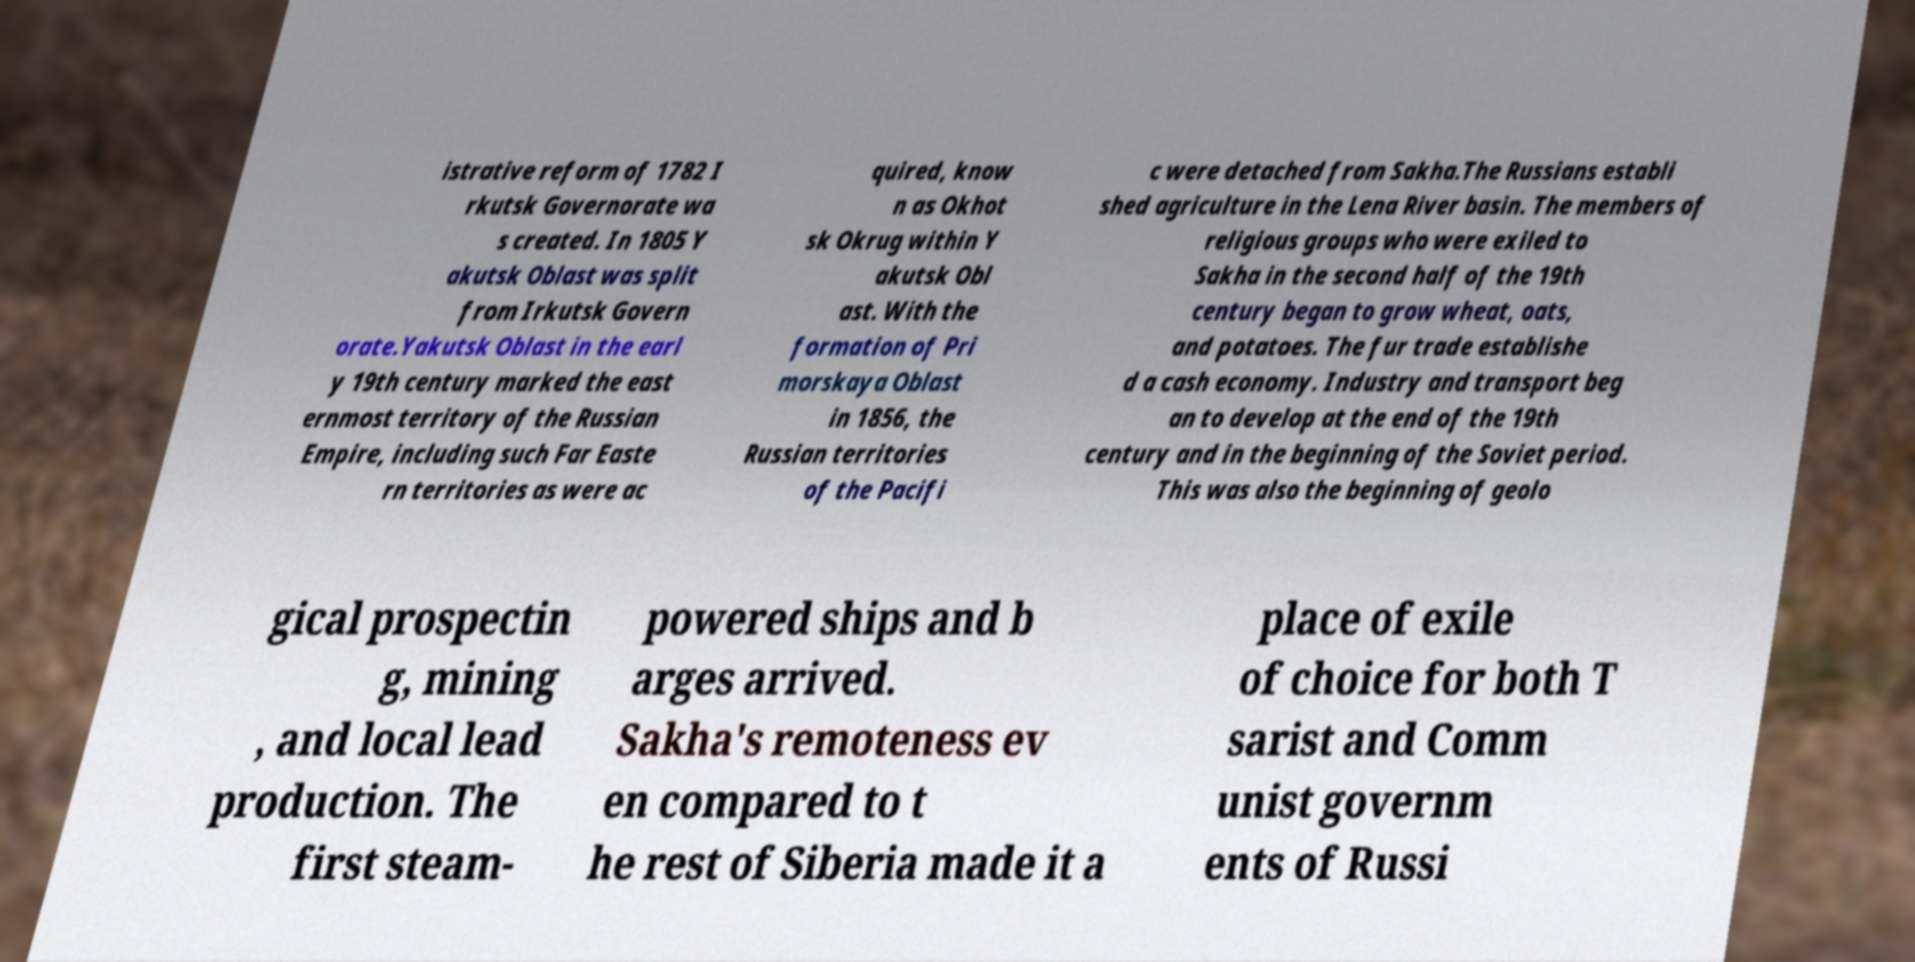Could you assist in decoding the text presented in this image and type it out clearly? istrative reform of 1782 I rkutsk Governorate wa s created. In 1805 Y akutsk Oblast was split from Irkutsk Govern orate.Yakutsk Oblast in the earl y 19th century marked the east ernmost territory of the Russian Empire, including such Far Easte rn territories as were ac quired, know n as Okhot sk Okrug within Y akutsk Obl ast. With the formation of Pri morskaya Oblast in 1856, the Russian territories of the Pacifi c were detached from Sakha.The Russians establi shed agriculture in the Lena River basin. The members of religious groups who were exiled to Sakha in the second half of the 19th century began to grow wheat, oats, and potatoes. The fur trade establishe d a cash economy. Industry and transport beg an to develop at the end of the 19th century and in the beginning of the Soviet period. This was also the beginning of geolo gical prospectin g, mining , and local lead production. The first steam- powered ships and b arges arrived. Sakha's remoteness ev en compared to t he rest of Siberia made it a place of exile of choice for both T sarist and Comm unist governm ents of Russi 